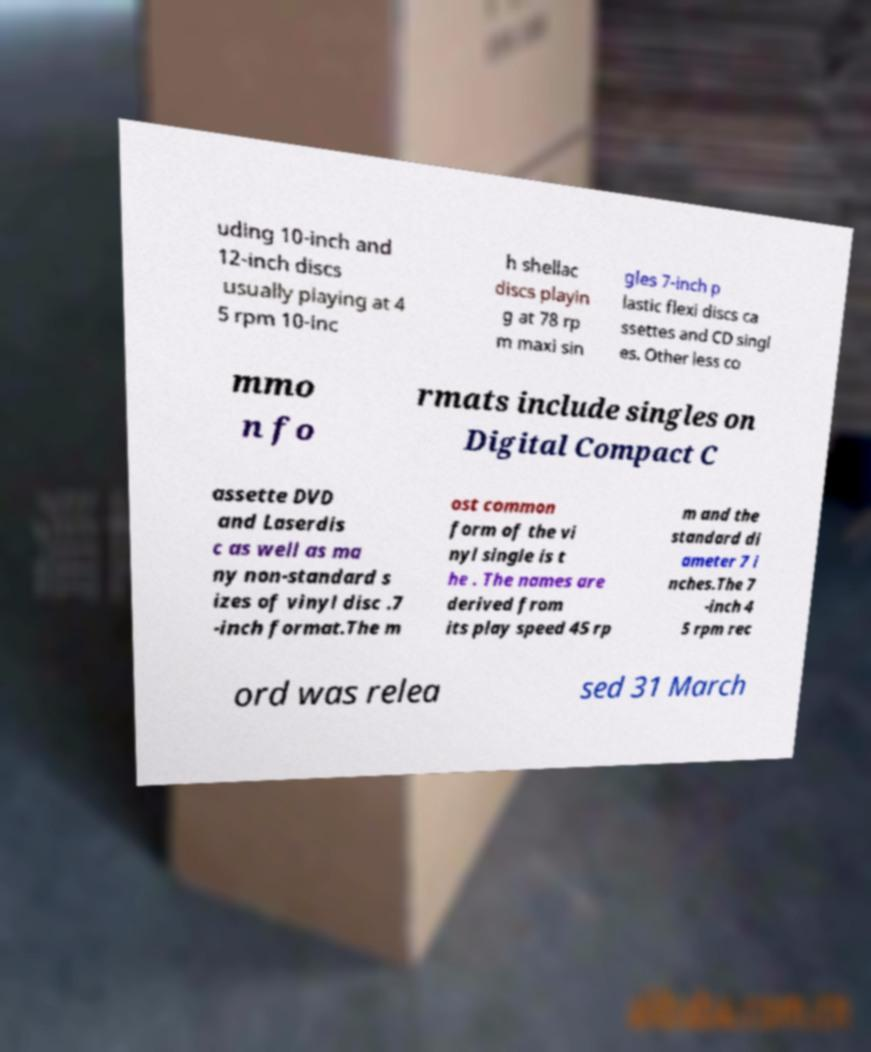Can you read and provide the text displayed in the image?This photo seems to have some interesting text. Can you extract and type it out for me? uding 10-inch and 12-inch discs usually playing at 4 5 rpm 10-inc h shellac discs playin g at 78 rp m maxi sin gles 7-inch p lastic flexi discs ca ssettes and CD singl es. Other less co mmo n fo rmats include singles on Digital Compact C assette DVD and Laserdis c as well as ma ny non-standard s izes of vinyl disc .7 -inch format.The m ost common form of the vi nyl single is t he . The names are derived from its play speed 45 rp m and the standard di ameter 7 i nches.The 7 -inch 4 5 rpm rec ord was relea sed 31 March 